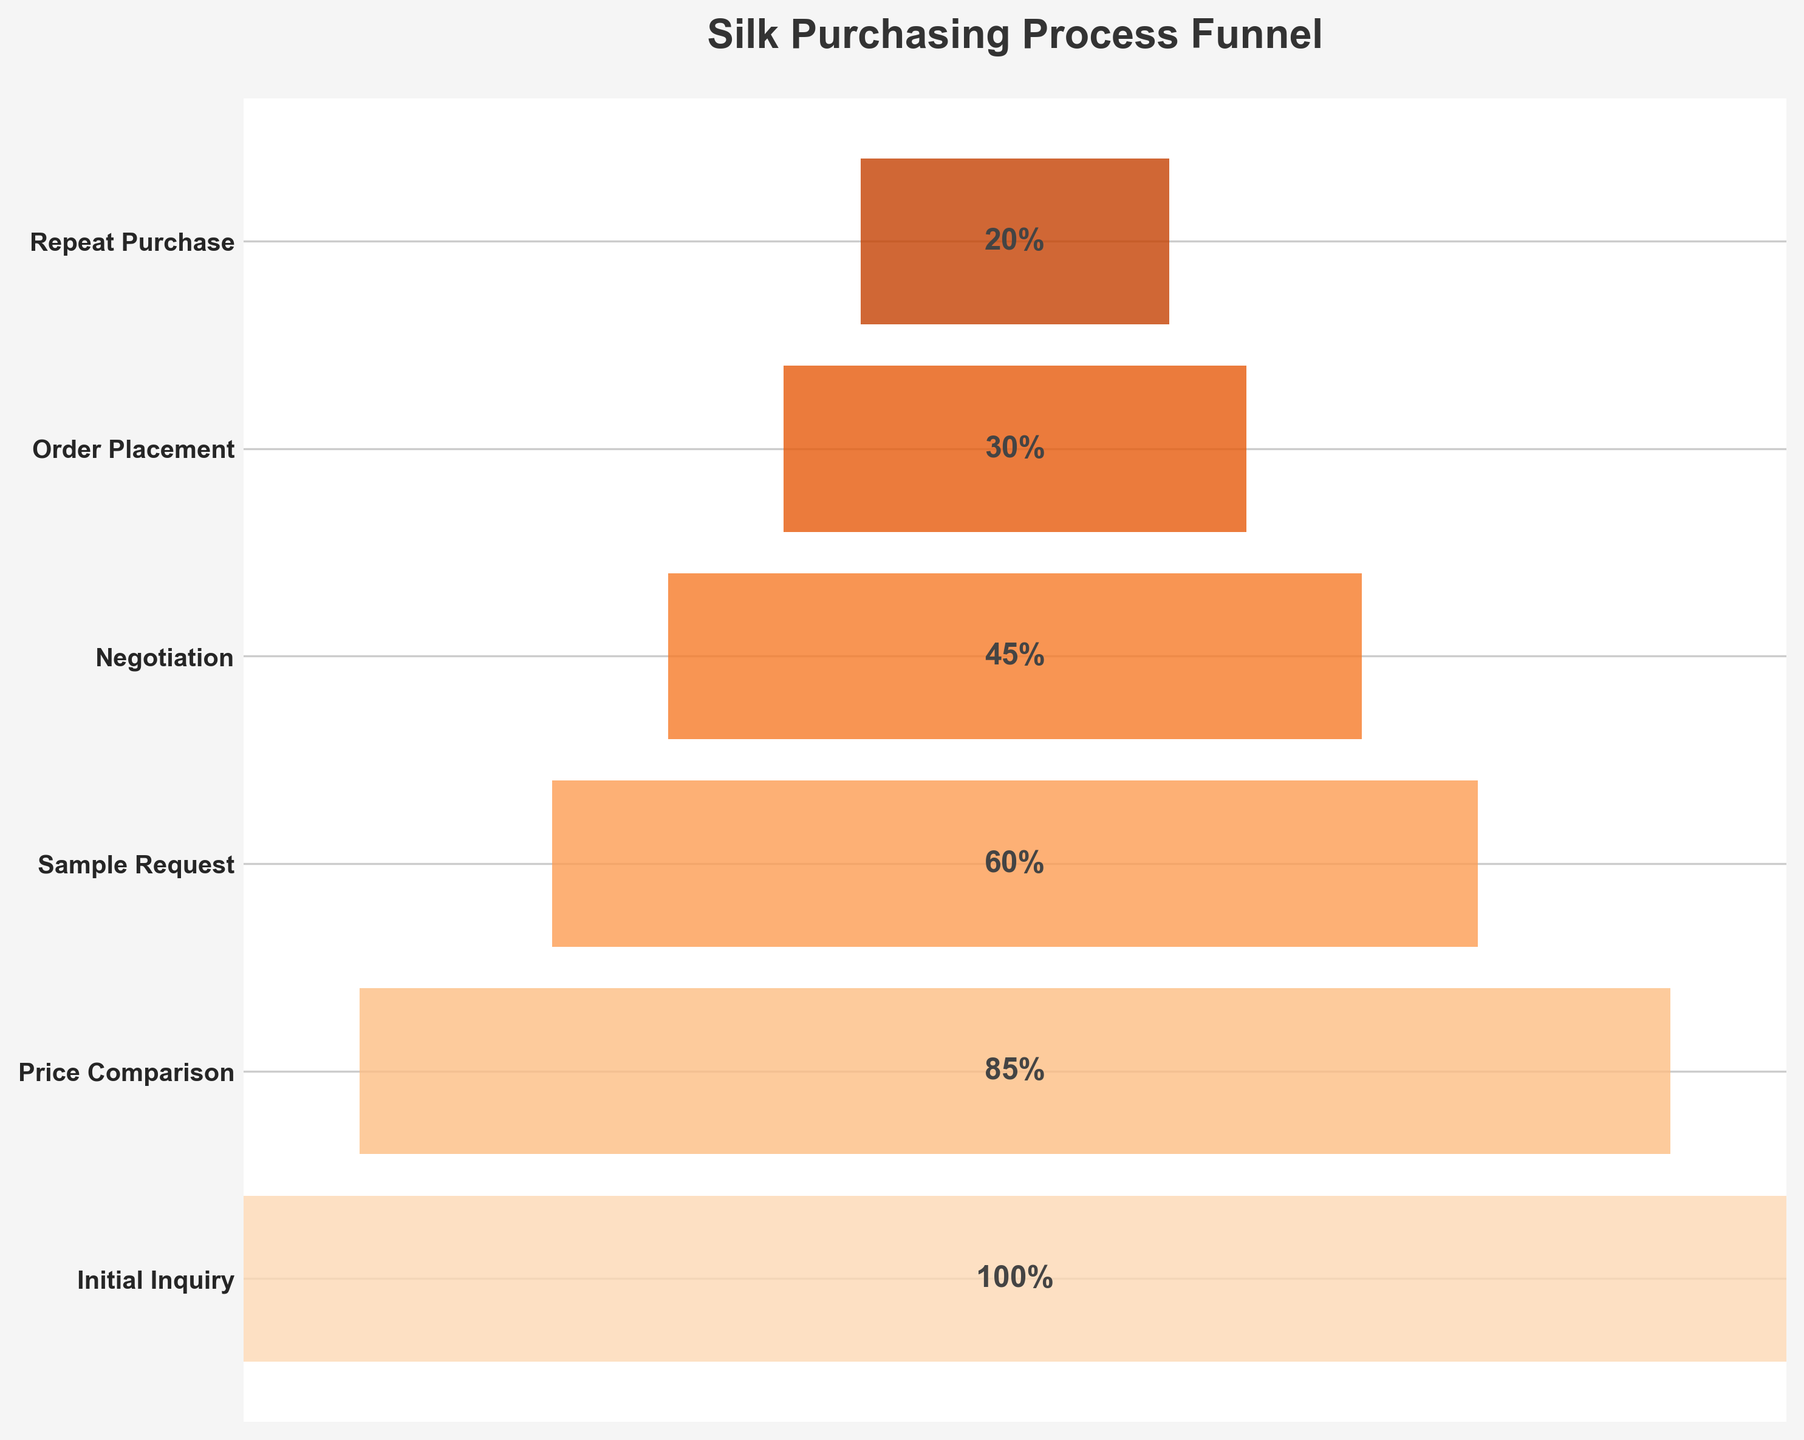What's the title of the figure? The title of the figure is usually located at the top and provides a summary of the chart's content. In this case, it reads "Silk Purchasing Process Funnel," directly explaining what the chart is depicting.
Answer: Silk Purchasing Process Funnel How many stages are shown in the funnel? By counting the horizontal bars in the funnel chart, we can determine there are six different stages.
Answer: Six Which stage has the highest customer retention rate? The highest customer retention rate corresponds to the first stage. In this chart, "Initial Inquiry" has the highest rate at 100%.
Answer: Initial Inquiry What is the retention rate difference between "Sample Request" and "Order Placement"? To find the retention rate difference between these two stages, subtract the percentage of "Order Placement" from "Sample Request" (60% - 30% = 30%).
Answer: 30% By what percentage does retention drop from "Price Comparison" to "Order Placement"? Calculate the difference in retention rates between "Price Comparison" and "Order Placement": 85% - 30% = 55%.
Answer: 55% What is the average retention rate across all stages? Sum all the percentages and divide by the number of stages: (100% + 85% + 60% + 45% + 30% + 20%) / 6 = 56.67%.
Answer: 56.67% Which stages have a retention rate less than 50%? Identify all the stages whose bars fall below the 50% mark. From the chart: "Negotiation", "Order Placement", and "Repeat Purchase" have rates of 45%, 30%, and 20%, respectively.
Answer: Negotiation, Order Placement, Repeat Purchase How much does the retention rate drop after the "Negotiaition" stage? To determine the drop, subtract the "Repeat Purchase" rate from the "Negotiation" rate: 45% - 20% = 25%.
Answer: 25% Is the retention rate at "Price Comparison" more or less than twice the rate at "Repeat Purchase"? Calculate twice the retention rate at "Repeat Purchase" (20% * 2 = 40%) and compare it with "Price Comparison" (85%). Since 85% > 40%, it is more.
Answer: More 